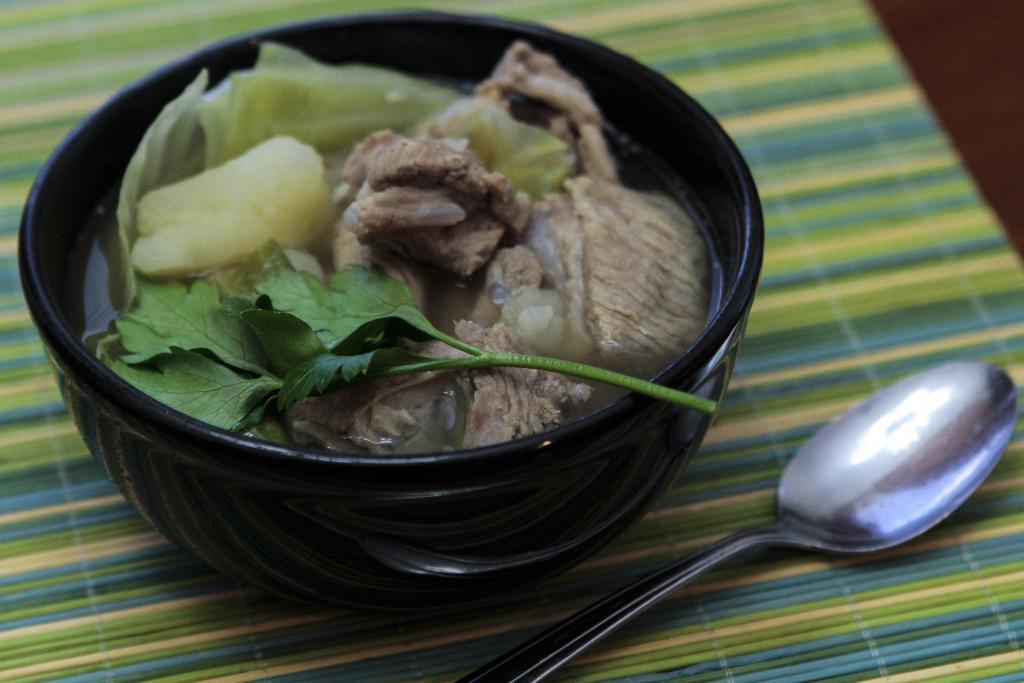What type of cooked food can be seen in the image? There is a cooked food item in the image, but the specific type is not mentioned. How is the food item presented in the image? The food item is served in a bowl. What utensil is provided for eating the food in the image? There is a spoon beside the bowl. What type of church can be seen in the image? There is no church present in the image. 